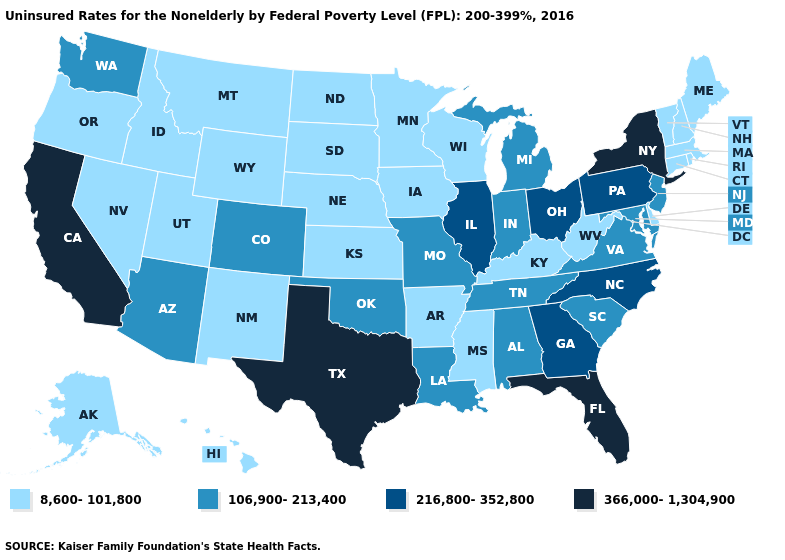Does Hawaii have a higher value than Arkansas?
Answer briefly. No. Among the states that border Alabama , does Florida have the highest value?
Concise answer only. Yes. What is the value of Connecticut?
Concise answer only. 8,600-101,800. What is the highest value in the West ?
Short answer required. 366,000-1,304,900. What is the value of Rhode Island?
Be succinct. 8,600-101,800. What is the value of Virginia?
Quick response, please. 106,900-213,400. What is the value of Delaware?
Write a very short answer. 8,600-101,800. Which states have the lowest value in the USA?
Be succinct. Alaska, Arkansas, Connecticut, Delaware, Hawaii, Idaho, Iowa, Kansas, Kentucky, Maine, Massachusetts, Minnesota, Mississippi, Montana, Nebraska, Nevada, New Hampshire, New Mexico, North Dakota, Oregon, Rhode Island, South Dakota, Utah, Vermont, West Virginia, Wisconsin, Wyoming. Among the states that border Oklahoma , does Missouri have the lowest value?
Be succinct. No. What is the value of Florida?
Keep it brief. 366,000-1,304,900. What is the lowest value in the USA?
Keep it brief. 8,600-101,800. Does the map have missing data?
Keep it brief. No. Which states have the lowest value in the South?
Write a very short answer. Arkansas, Delaware, Kentucky, Mississippi, West Virginia. Which states hav the highest value in the South?
Quick response, please. Florida, Texas. What is the value of Indiana?
Keep it brief. 106,900-213,400. 